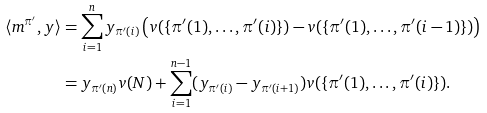Convert formula to latex. <formula><loc_0><loc_0><loc_500><loc_500>\langle m ^ { \pi ^ { \prime } } , y \rangle & = \sum _ { i = 1 } ^ { n } y _ { \pi ^ { \prime } ( i ) } \left ( v ( \{ \pi ^ { \prime } ( 1 ) , \dots , \pi ^ { \prime } ( i ) \} ) - v ( \{ \pi ^ { \prime } ( 1 ) , \dots , \pi ^ { \prime } ( i - 1 ) \} ) \right ) \\ & = y _ { \pi ^ { \prime } ( n ) } v ( N ) + \sum _ { i = 1 } ^ { n - 1 } ( y _ { \pi ^ { \prime } ( i ) } - y _ { \pi ^ { \prime } ( i + 1 ) } ) v ( \{ \pi ^ { \prime } ( 1 ) , \dots , \pi ^ { \prime } ( i ) \} ) .</formula> 